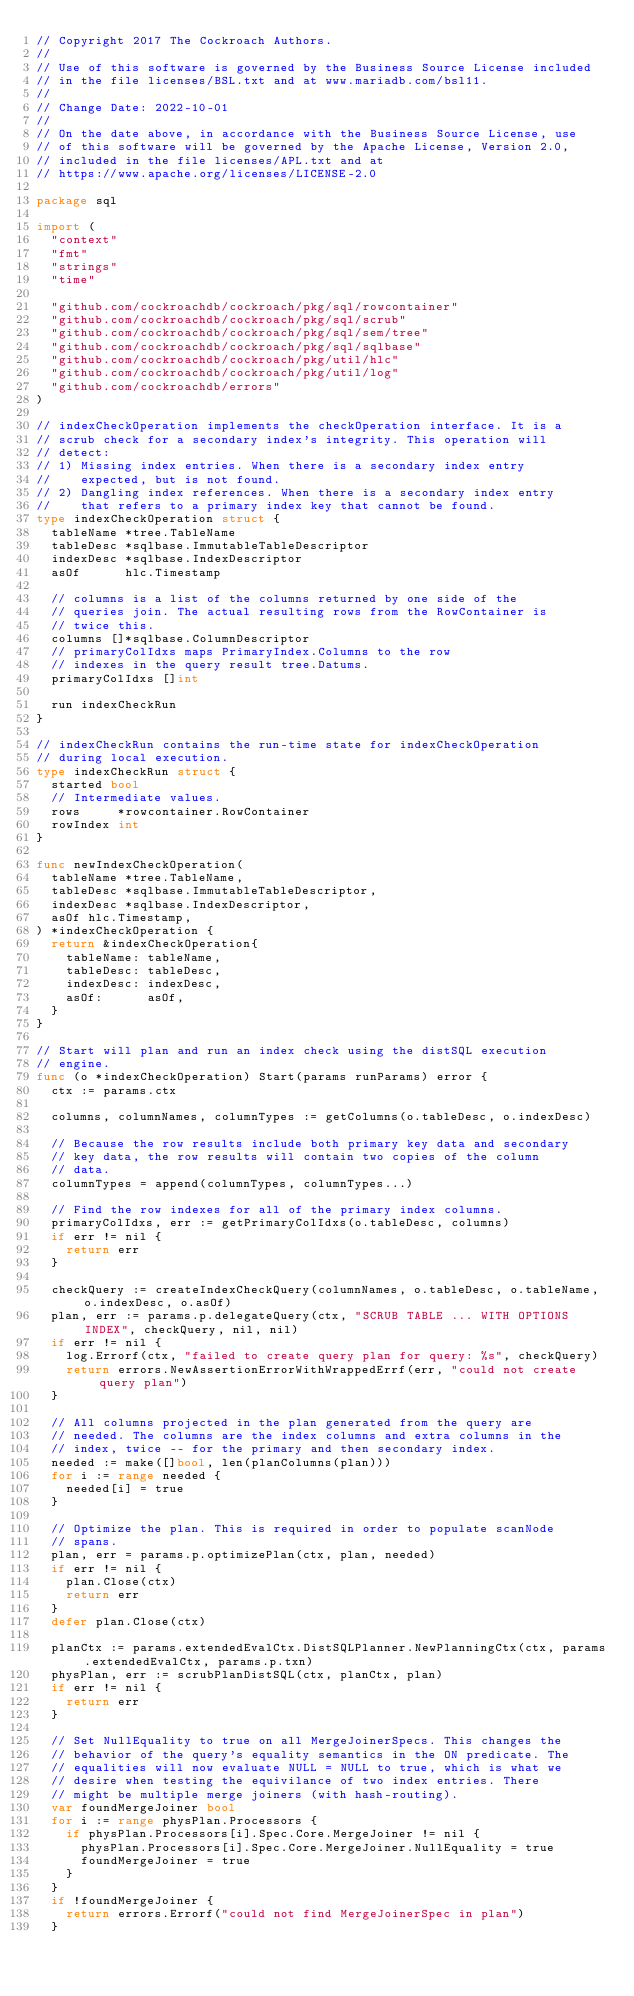Convert code to text. <code><loc_0><loc_0><loc_500><loc_500><_Go_>// Copyright 2017 The Cockroach Authors.
//
// Use of this software is governed by the Business Source License included
// in the file licenses/BSL.txt and at www.mariadb.com/bsl11.
//
// Change Date: 2022-10-01
//
// On the date above, in accordance with the Business Source License, use
// of this software will be governed by the Apache License, Version 2.0,
// included in the file licenses/APL.txt and at
// https://www.apache.org/licenses/LICENSE-2.0

package sql

import (
	"context"
	"fmt"
	"strings"
	"time"

	"github.com/cockroachdb/cockroach/pkg/sql/rowcontainer"
	"github.com/cockroachdb/cockroach/pkg/sql/scrub"
	"github.com/cockroachdb/cockroach/pkg/sql/sem/tree"
	"github.com/cockroachdb/cockroach/pkg/sql/sqlbase"
	"github.com/cockroachdb/cockroach/pkg/util/hlc"
	"github.com/cockroachdb/cockroach/pkg/util/log"
	"github.com/cockroachdb/errors"
)

// indexCheckOperation implements the checkOperation interface. It is a
// scrub check for a secondary index's integrity. This operation will
// detect:
// 1) Missing index entries. When there is a secondary index entry
//    expected, but is not found.
// 2) Dangling index references. When there is a secondary index entry
//    that refers to a primary index key that cannot be found.
type indexCheckOperation struct {
	tableName *tree.TableName
	tableDesc *sqlbase.ImmutableTableDescriptor
	indexDesc *sqlbase.IndexDescriptor
	asOf      hlc.Timestamp

	// columns is a list of the columns returned by one side of the
	// queries join. The actual resulting rows from the RowContainer is
	// twice this.
	columns []*sqlbase.ColumnDescriptor
	// primaryColIdxs maps PrimaryIndex.Columns to the row
	// indexes in the query result tree.Datums.
	primaryColIdxs []int

	run indexCheckRun
}

// indexCheckRun contains the run-time state for indexCheckOperation
// during local execution.
type indexCheckRun struct {
	started bool
	// Intermediate values.
	rows     *rowcontainer.RowContainer
	rowIndex int
}

func newIndexCheckOperation(
	tableName *tree.TableName,
	tableDesc *sqlbase.ImmutableTableDescriptor,
	indexDesc *sqlbase.IndexDescriptor,
	asOf hlc.Timestamp,
) *indexCheckOperation {
	return &indexCheckOperation{
		tableName: tableName,
		tableDesc: tableDesc,
		indexDesc: indexDesc,
		asOf:      asOf,
	}
}

// Start will plan and run an index check using the distSQL execution
// engine.
func (o *indexCheckOperation) Start(params runParams) error {
	ctx := params.ctx

	columns, columnNames, columnTypes := getColumns(o.tableDesc, o.indexDesc)

	// Because the row results include both primary key data and secondary
	// key data, the row results will contain two copies of the column
	// data.
	columnTypes = append(columnTypes, columnTypes...)

	// Find the row indexes for all of the primary index columns.
	primaryColIdxs, err := getPrimaryColIdxs(o.tableDesc, columns)
	if err != nil {
		return err
	}

	checkQuery := createIndexCheckQuery(columnNames, o.tableDesc, o.tableName, o.indexDesc, o.asOf)
	plan, err := params.p.delegateQuery(ctx, "SCRUB TABLE ... WITH OPTIONS INDEX", checkQuery, nil, nil)
	if err != nil {
		log.Errorf(ctx, "failed to create query plan for query: %s", checkQuery)
		return errors.NewAssertionErrorWithWrappedErrf(err, "could not create query plan")
	}

	// All columns projected in the plan generated from the query are
	// needed. The columns are the index columns and extra columns in the
	// index, twice -- for the primary and then secondary index.
	needed := make([]bool, len(planColumns(plan)))
	for i := range needed {
		needed[i] = true
	}

	// Optimize the plan. This is required in order to populate scanNode
	// spans.
	plan, err = params.p.optimizePlan(ctx, plan, needed)
	if err != nil {
		plan.Close(ctx)
		return err
	}
	defer plan.Close(ctx)

	planCtx := params.extendedEvalCtx.DistSQLPlanner.NewPlanningCtx(ctx, params.extendedEvalCtx, params.p.txn)
	physPlan, err := scrubPlanDistSQL(ctx, planCtx, plan)
	if err != nil {
		return err
	}

	// Set NullEquality to true on all MergeJoinerSpecs. This changes the
	// behavior of the query's equality semantics in the ON predicate. The
	// equalities will now evaluate NULL = NULL to true, which is what we
	// desire when testing the equivilance of two index entries. There
	// might be multiple merge joiners (with hash-routing).
	var foundMergeJoiner bool
	for i := range physPlan.Processors {
		if physPlan.Processors[i].Spec.Core.MergeJoiner != nil {
			physPlan.Processors[i].Spec.Core.MergeJoiner.NullEquality = true
			foundMergeJoiner = true
		}
	}
	if !foundMergeJoiner {
		return errors.Errorf("could not find MergeJoinerSpec in plan")
	}
</code> 